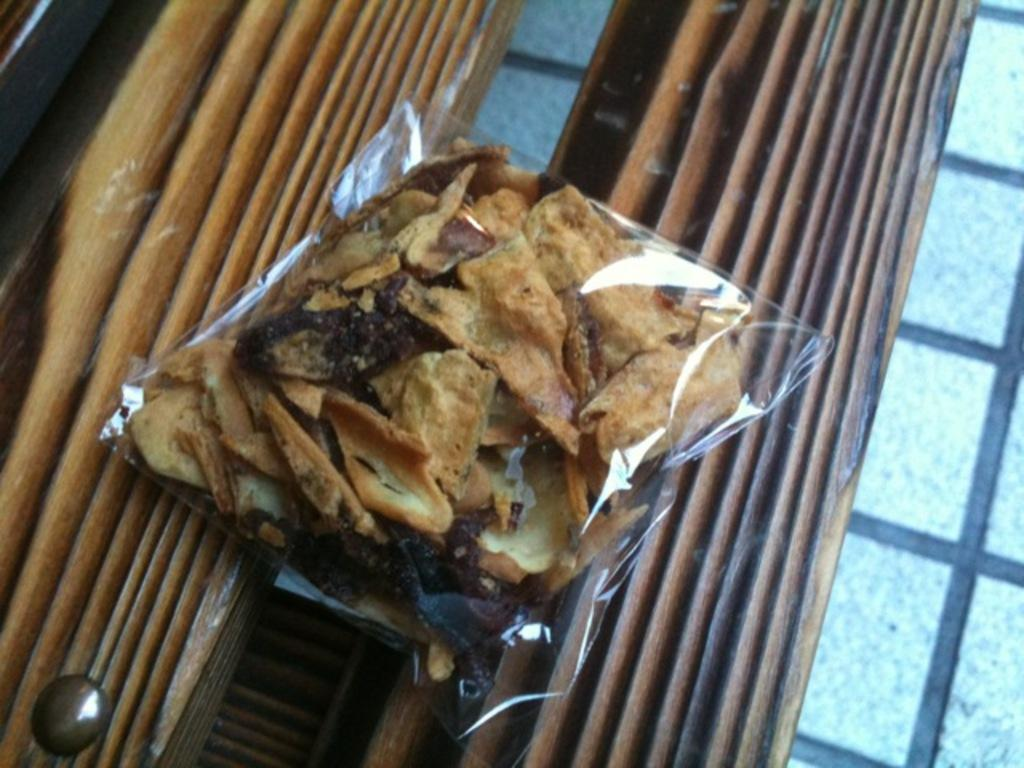What is the main object in the image? There is a food packet in the image. Where is the food packet placed? The food packet is placed on a wooden surface. Can you describe the surface where the food packet is placed? The wooden surface suggests that there might be a table in the image. How many beds can be seen in the image? There are no beds present in the image; it features a food packet placed on a wooden surface. What type of beast is visible in the image? There is no beast present in the image. 